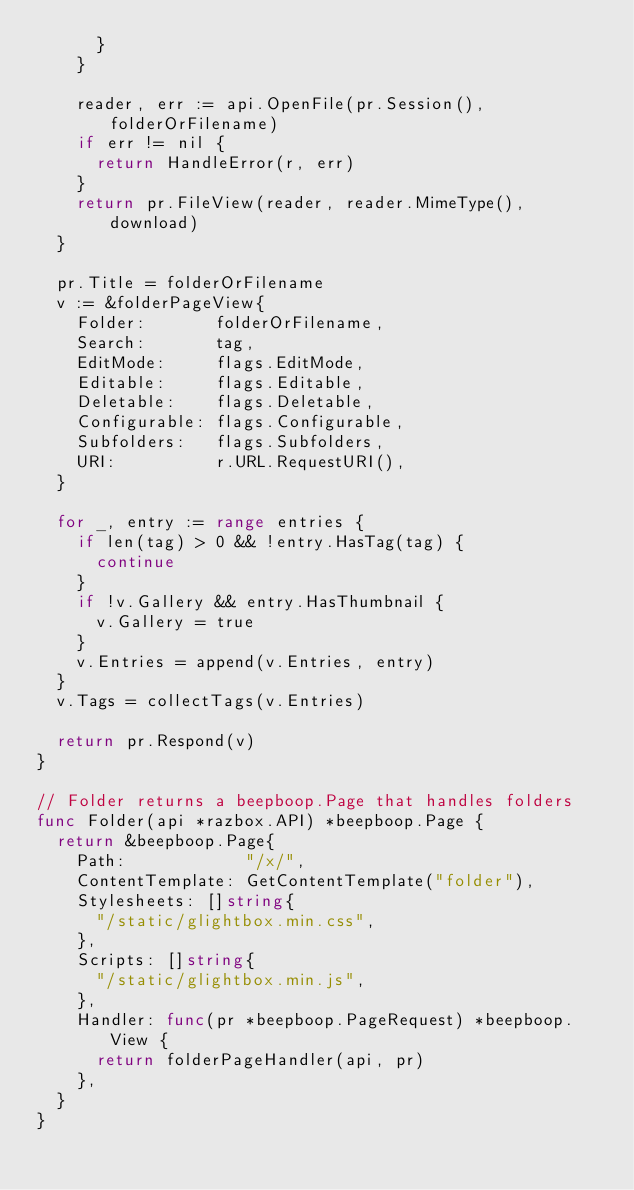Convert code to text. <code><loc_0><loc_0><loc_500><loc_500><_Go_>			}
		}

		reader, err := api.OpenFile(pr.Session(), folderOrFilename)
		if err != nil {
			return HandleError(r, err)
		}
		return pr.FileView(reader, reader.MimeType(), download)
	}

	pr.Title = folderOrFilename
	v := &folderPageView{
		Folder:       folderOrFilename,
		Search:       tag,
		EditMode:     flags.EditMode,
		Editable:     flags.Editable,
		Deletable:    flags.Deletable,
		Configurable: flags.Configurable,
		Subfolders:   flags.Subfolders,
		URI:          r.URL.RequestURI(),
	}

	for _, entry := range entries {
		if len(tag) > 0 && !entry.HasTag(tag) {
			continue
		}
		if !v.Gallery && entry.HasThumbnail {
			v.Gallery = true
		}
		v.Entries = append(v.Entries, entry)
	}
	v.Tags = collectTags(v.Entries)

	return pr.Respond(v)
}

// Folder returns a beepboop.Page that handles folders
func Folder(api *razbox.API) *beepboop.Page {
	return &beepboop.Page{
		Path:            "/x/",
		ContentTemplate: GetContentTemplate("folder"),
		Stylesheets: []string{
			"/static/glightbox.min.css",
		},
		Scripts: []string{
			"/static/glightbox.min.js",
		},
		Handler: func(pr *beepboop.PageRequest) *beepboop.View {
			return folderPageHandler(api, pr)
		},
	}
}
</code> 